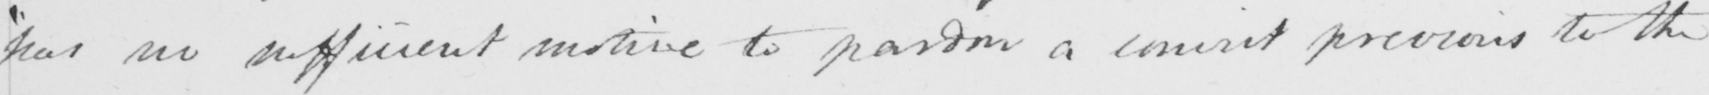Can you read and transcribe this handwriting? " has no sufficient motive to pardon a convict previous to the 